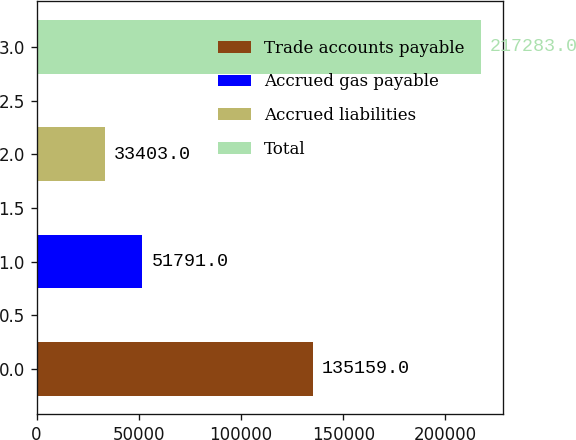Convert chart to OTSL. <chart><loc_0><loc_0><loc_500><loc_500><bar_chart><fcel>Trade accounts payable<fcel>Accrued gas payable<fcel>Accrued liabilities<fcel>Total<nl><fcel>135159<fcel>51791<fcel>33403<fcel>217283<nl></chart> 